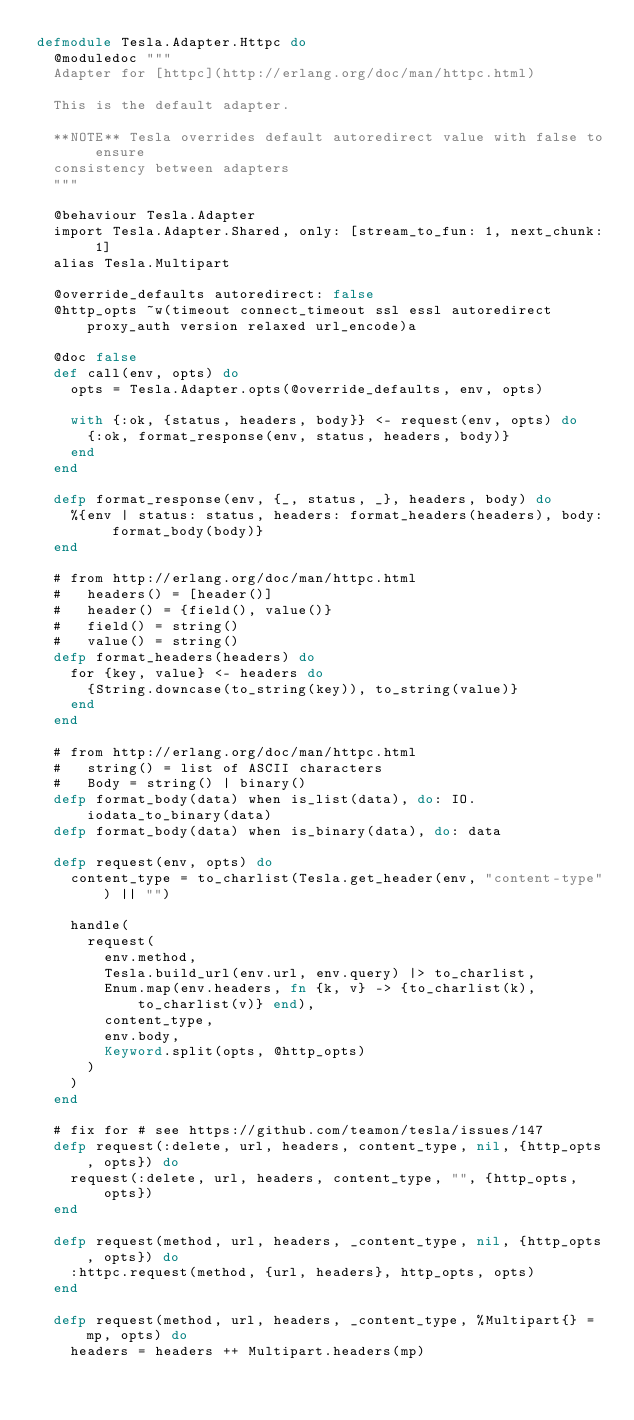<code> <loc_0><loc_0><loc_500><loc_500><_Elixir_>defmodule Tesla.Adapter.Httpc do
  @moduledoc """
  Adapter for [httpc](http://erlang.org/doc/man/httpc.html)

  This is the default adapter.

  **NOTE** Tesla overrides default autoredirect value with false to ensure
  consistency between adapters
  """

  @behaviour Tesla.Adapter
  import Tesla.Adapter.Shared, only: [stream_to_fun: 1, next_chunk: 1]
  alias Tesla.Multipart

  @override_defaults autoredirect: false
  @http_opts ~w(timeout connect_timeout ssl essl autoredirect proxy_auth version relaxed url_encode)a

  @doc false
  def call(env, opts) do
    opts = Tesla.Adapter.opts(@override_defaults, env, opts)

    with {:ok, {status, headers, body}} <- request(env, opts) do
      {:ok, format_response(env, status, headers, body)}
    end
  end

  defp format_response(env, {_, status, _}, headers, body) do
    %{env | status: status, headers: format_headers(headers), body: format_body(body)}
  end

  # from http://erlang.org/doc/man/httpc.html
  #   headers() = [header()]
  #   header() = {field(), value()}
  #   field() = string()
  #   value() = string()
  defp format_headers(headers) do
    for {key, value} <- headers do
      {String.downcase(to_string(key)), to_string(value)}
    end
  end

  # from http://erlang.org/doc/man/httpc.html
  #   string() = list of ASCII characters
  #   Body = string() | binary()
  defp format_body(data) when is_list(data), do: IO.iodata_to_binary(data)
  defp format_body(data) when is_binary(data), do: data

  defp request(env, opts) do
    content_type = to_charlist(Tesla.get_header(env, "content-type") || "")

    handle(
      request(
        env.method,
        Tesla.build_url(env.url, env.query) |> to_charlist,
        Enum.map(env.headers, fn {k, v} -> {to_charlist(k), to_charlist(v)} end),
        content_type,
        env.body,
        Keyword.split(opts, @http_opts)
      )
    )
  end

  # fix for # see https://github.com/teamon/tesla/issues/147
  defp request(:delete, url, headers, content_type, nil, {http_opts, opts}) do
    request(:delete, url, headers, content_type, "", {http_opts, opts})
  end

  defp request(method, url, headers, _content_type, nil, {http_opts, opts}) do
    :httpc.request(method, {url, headers}, http_opts, opts)
  end

  defp request(method, url, headers, _content_type, %Multipart{} = mp, opts) do
    headers = headers ++ Multipart.headers(mp)</code> 